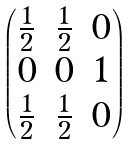Convert formula to latex. <formula><loc_0><loc_0><loc_500><loc_500>\begin{pmatrix} \frac { 1 } { 2 } & \frac { 1 } { 2 } & 0 \\ 0 & 0 & 1 \\ \frac { 1 } { 2 } & \frac { 1 } { 2 } & 0 \\ \end{pmatrix}</formula> 